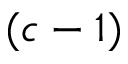<formula> <loc_0><loc_0><loc_500><loc_500>( c - 1 )</formula> 